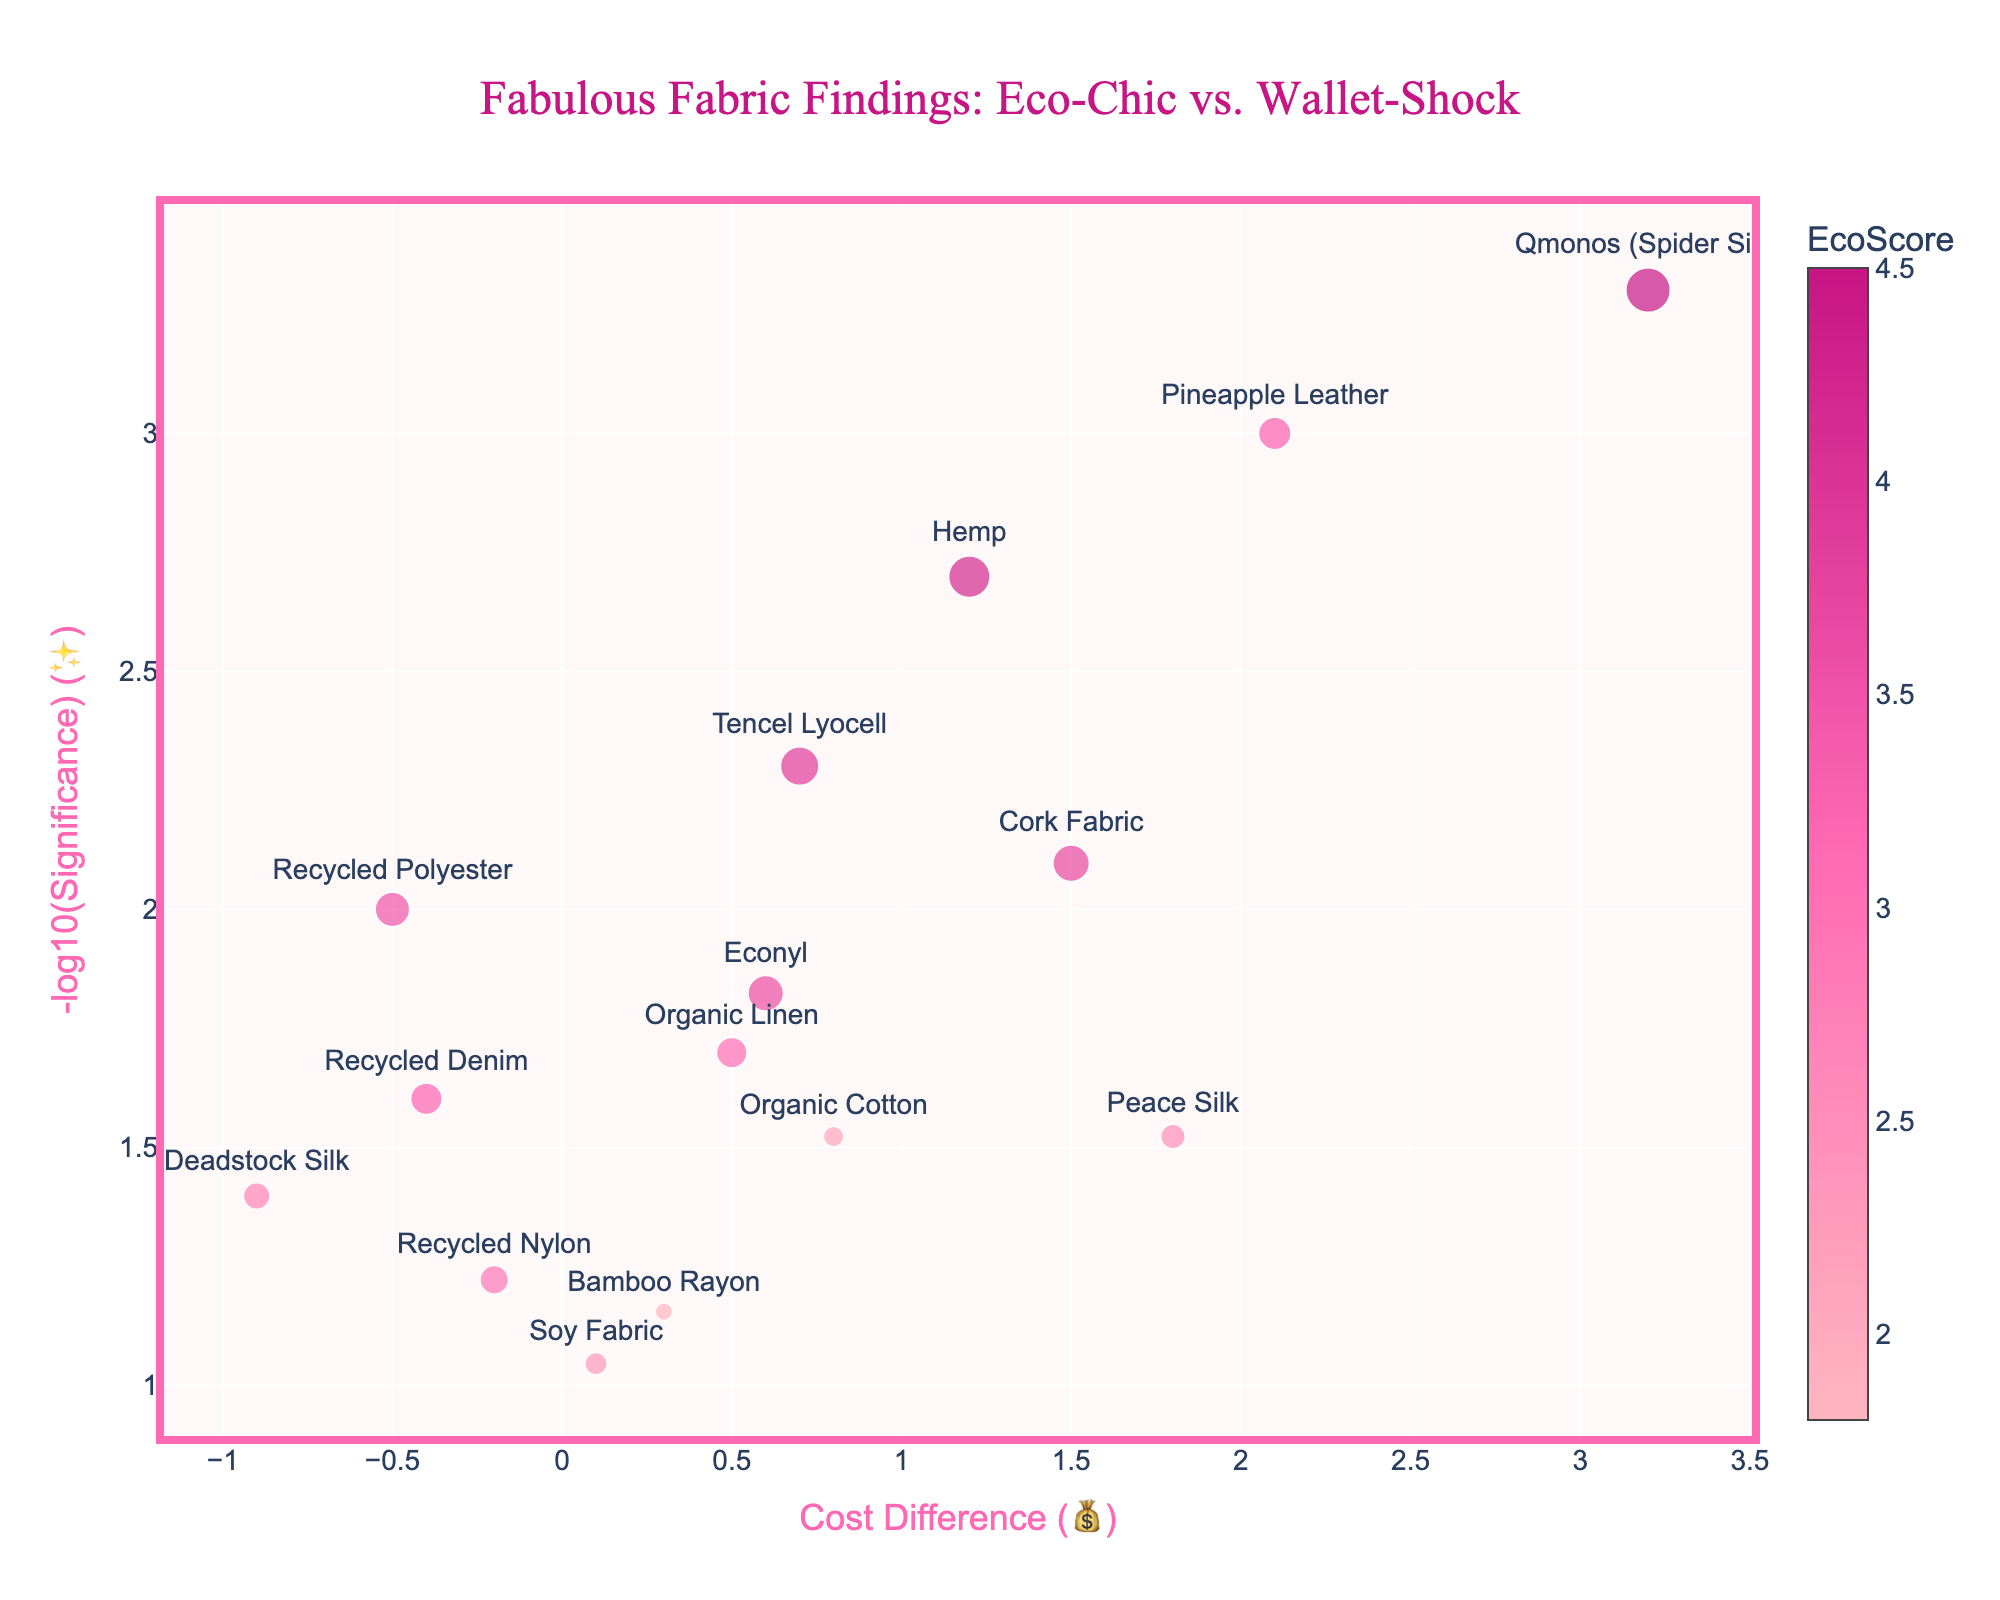What is the title of the plot? The title is often prominently displayed at the top of the plot. Looking there, you'll see it reads "Fabulous Fabric Findings: Eco-Chic vs. Wallet-Shock".
Answer: Fabulous Fabric Findings: Eco-Chic vs. Wallet-Shock How many fabric types are represented in the plot? Each marker on the plot represents a different fabric type. By counting the markers or referring to the legend, you can see that there are 15 distinct fabrics listed.
Answer: 15 Which fabric shows the most significant difference in production cost? Significance is measured by -log10(Significance) on the y-axis. The fabric with the highest y-value has the lowest p-value, indicating the most significant cost difference. Qmonos (Spider Silk) has the highest y-value.
Answer: Qmonos (Spider Silk) What is the cost difference for Pineapple Leather? The x-axis represents the cost difference. Locate the marker labeled "Pineapple Leather" and read its x-coordinate, which is 2.1.
Answer: 2.1 Which fabric has the highest eco-friendliness score? The EcoScore is represented by the color and size of the markers. Find the largest and darkest marker, which corresponds to Qmonos (Spider Silk) with an EcoScore of 4.5.
Answer: Qmonos (Spider Silk) What is the significance value for Organic Cotton? Significance values are transformed using -log10. Find Organic Cotton on the y-axis and reverse the -log10 transformation: 0.03 is the significance for Organic Cotton.
Answer: 0.03 Which two fabrics have a negative cost difference? Fabrics with markers placed on the left side of the vertical axis (negative x-values) have negative cost differences. Recycled Polyester and Deadstock Silk plot to the left.
Answer: Recycled Polyester, Deadstock Silk What is the combined eco-friendliness score of all fabrics with a positive cost difference? Sum the EcoScores for fabrics placed on the right side of the axis (positive x-values): Organic Cotton, Bamboo Rayon, Hemp, Tencel Lyocell, Pineapple Leather, Cork Fabric, Organic Linen, Peace Silk, Soy Fabric, and Qmonos (Spider Silk). Adding their scores: 2.1+1.8+4.2+3.9+3.3+3.7+3.1+2.5+2.3+4.5 = 31.4.
Answer: 31.4 Which fabrics have a cost difference greater than 1 and what are their eco-friendliness scores? Locate the markers placed to the right of 1 on the x-axis and read their EcoScores. These fabrics and their corresponding scores are Hemp (4.2), Pineapple Leather (3.3), Cork Fabric (3.7), Peace Silk (2.5), and Qmonos (Spider Silk) (4.5).
Answer: Hemp (4.2), Pineapple Leather (3.3), Cork Fabric (3.7), Peace Silk (2.5), Qmonos (Spider Silk) (4.5) Which fabric has the lowest significance, and what is its EcoScore? The y-axis measures -log10(Significance); the fabric with the lowest y-value has the highest significance (lowest -log10). Soy Fabric sits the lowest on the scale, with an EcoScore of 2.3.
Answer: Soy Fabric, 2.3 